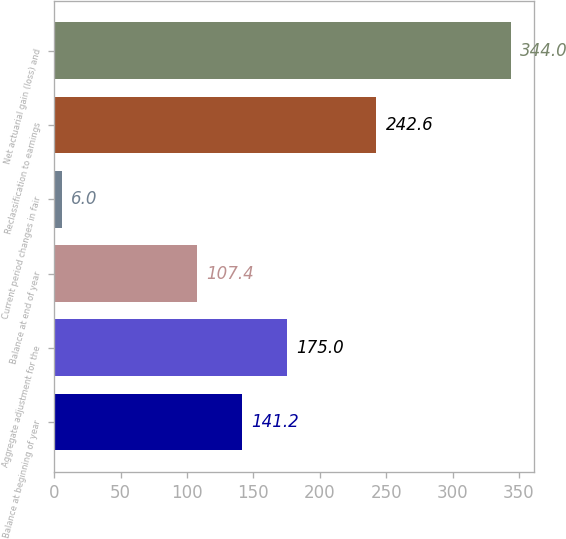Convert chart. <chart><loc_0><loc_0><loc_500><loc_500><bar_chart><fcel>Balance at beginning of year<fcel>Aggregate adjustment for the<fcel>Balance at end of year<fcel>Current period changes in fair<fcel>Reclassification to earnings<fcel>Net actuarial gain (loss) and<nl><fcel>141.2<fcel>175<fcel>107.4<fcel>6<fcel>242.6<fcel>344<nl></chart> 